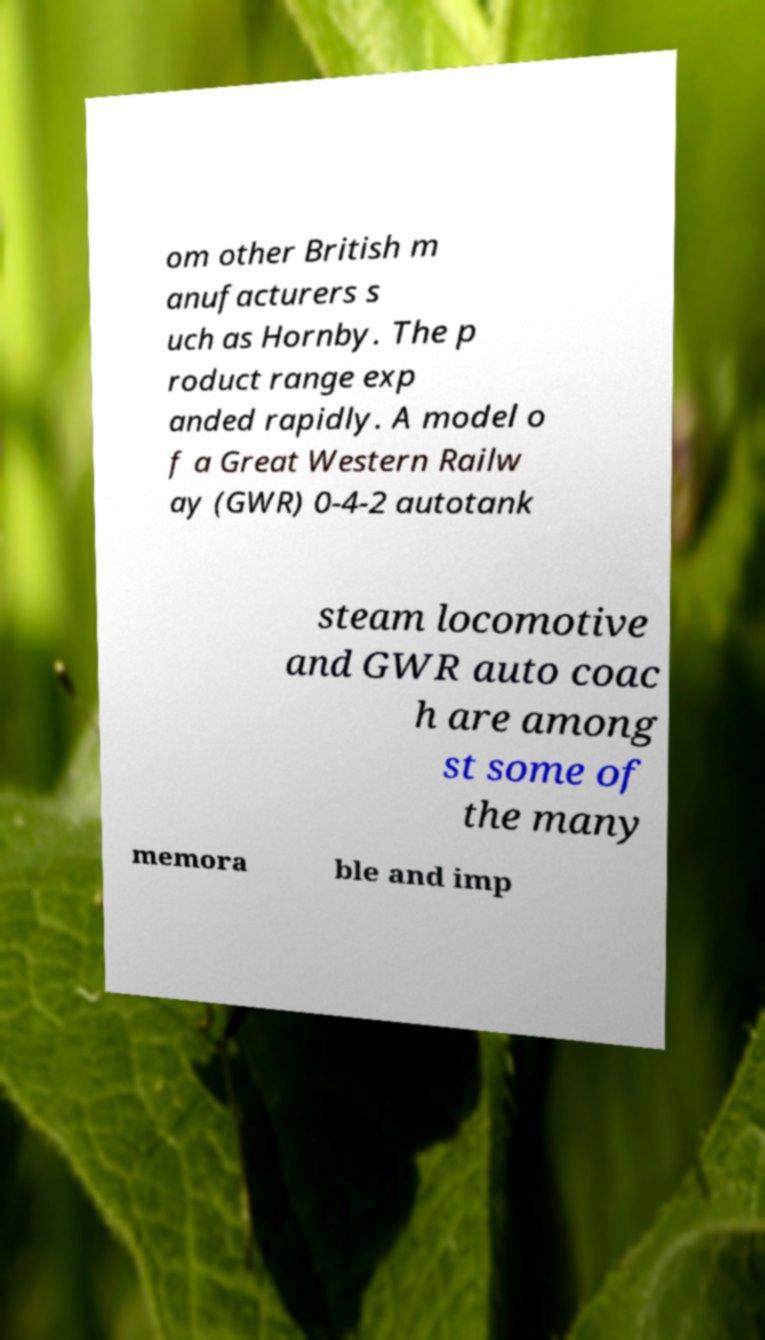Can you read and provide the text displayed in the image?This photo seems to have some interesting text. Can you extract and type it out for me? om other British m anufacturers s uch as Hornby. The p roduct range exp anded rapidly. A model o f a Great Western Railw ay (GWR) 0-4-2 autotank steam locomotive and GWR auto coac h are among st some of the many memora ble and imp 